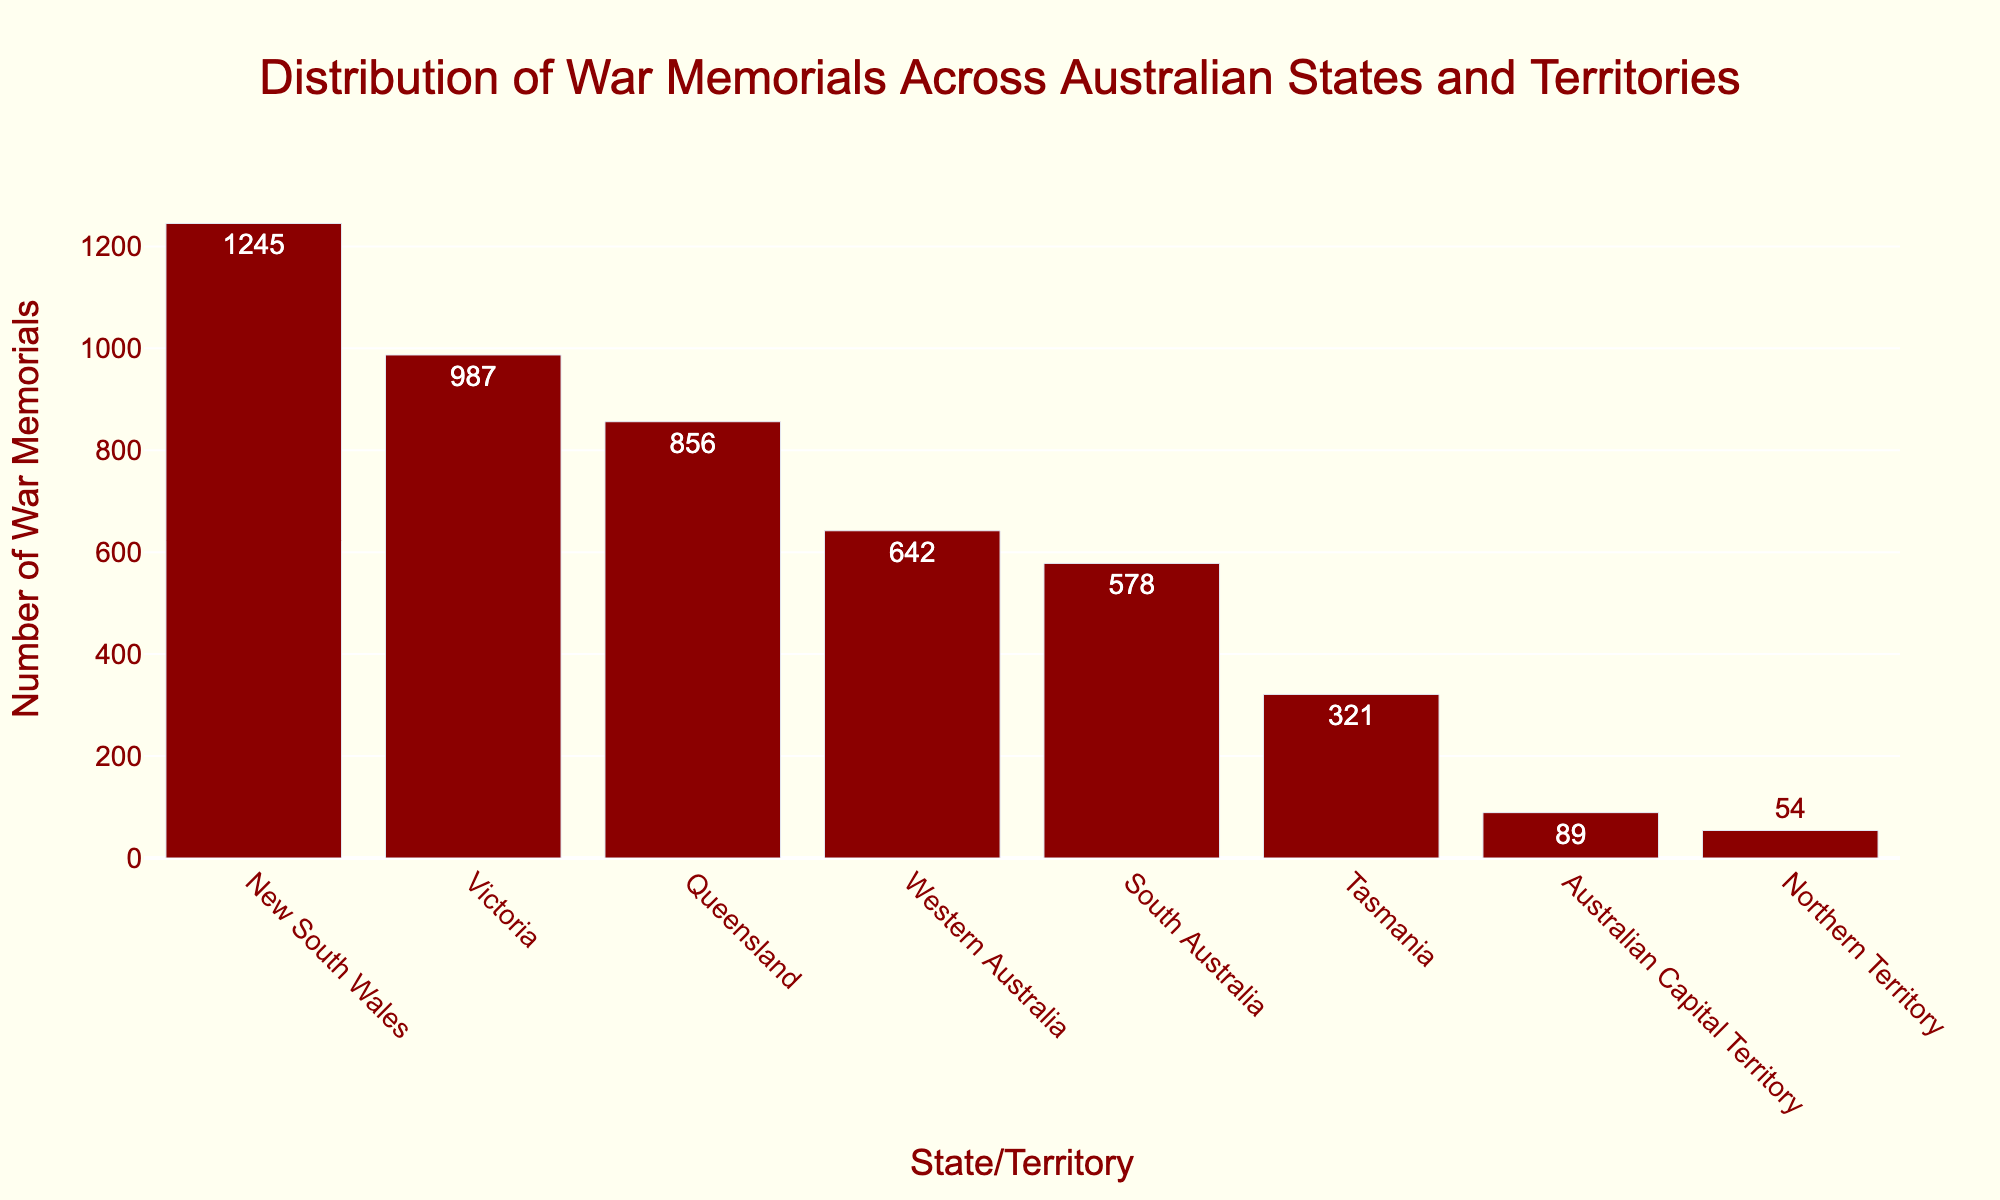Which state/territory has the highest number of war memorials? The highest bar indicates the state/territory with the most war memorials. New South Wales has the tallest bar.
Answer: New South Wales What is the difference in the number of war memorials between New South Wales and Victoria? Subtract the number of war memorials in Victoria from the number in New South Wales: 1245 - 987 = 258.
Answer: 258 How many war memorials are there in Western Australia and South Australia combined? Add the number of war memorials for Western Australia and South Australia: 642 + 578 = 1220.
Answer: 1220 Which state/territory has fewer war memorials: Tasmania or Northern Territory? Compare the height of the bars for Tasmania and Northern Territory. Tasmania has 321 and Northern Territory has 54 war memorials.
Answer: Northern Territory What is the total number of war memorials represented in the figure? Sum the number of war memorials across all states and territories: 1245 + 987 + 856 + 642 + 578 + 321 + 89 + 54 = 4772.
Answer: 4772 What is the average number of war memorials per state/territory? Divide the total number of war memorials by the number of states and territories: 4772 / 8 ≈ 596.5.
Answer: 596.5 Which state/territory has the second highest number of war memorials? Identify the second tallest bar after New South Wales. Victoria has the second highest number of war memorials.
Answer: Victoria How many more war memorials does Queensland have compared to Northern Territory? Subtract the number of war memorials in Northern Territory from the number in Queensland: 856 - 54 = 802.
Answer: 802 Rank the states/territories by the number of war memorials from highest to lowest. List the states/territories by the height of the bars, starting with the tallest.
Answer: New South Wales, Victoria, Queensland, Western Australia, South Australia, Tasmania, Australian Capital Territory, Northern Territory What percentage of the total war memorials does New South Wales have? Divide the number of war memorials in New South Wales by the total number of war memorials, and multiply by 100: (1245 / 4772) × 100 ≈ 26.1%.
Answer: 26.1% 